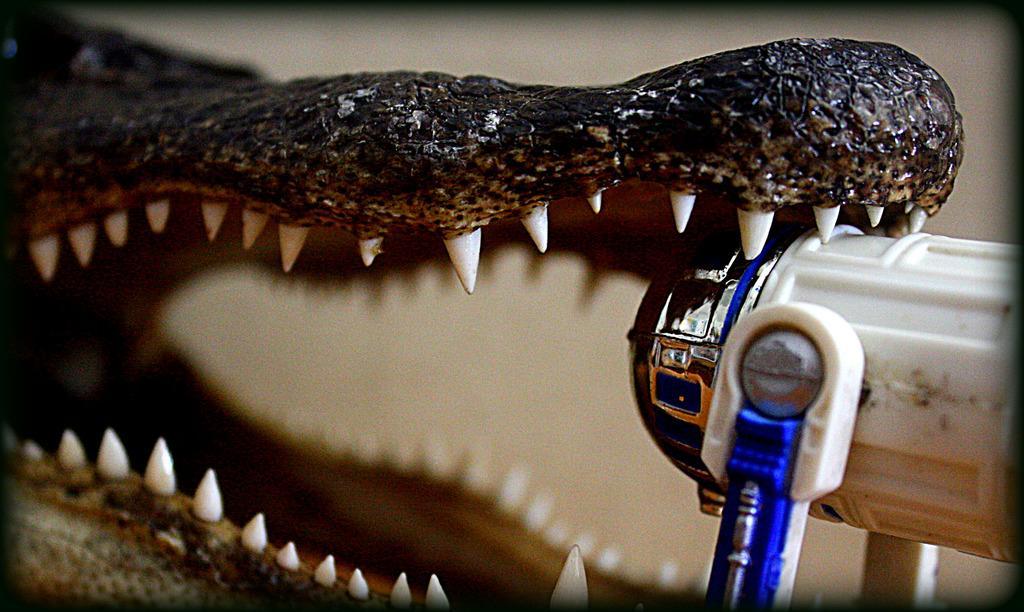In one or two sentences, can you explain what this image depicts? In this image there is a sculpture of a crocodile, on the right side there is an object. 